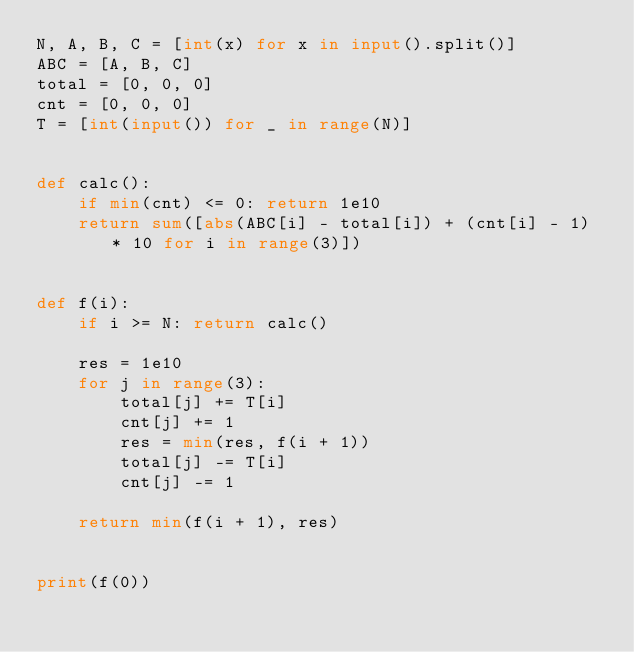<code> <loc_0><loc_0><loc_500><loc_500><_Python_>N, A, B, C = [int(x) for x in input().split()]
ABC = [A, B, C]
total = [0, 0, 0]
cnt = [0, 0, 0]
T = [int(input()) for _ in range(N)]


def calc():
    if min(cnt) <= 0: return 1e10
    return sum([abs(ABC[i] - total[i]) + (cnt[i] - 1) * 10 for i in range(3)])


def f(i):
    if i >= N: return calc()

    res = 1e10
    for j in range(3):
        total[j] += T[i]
        cnt[j] += 1
        res = min(res, f(i + 1))
        total[j] -= T[i]
        cnt[j] -= 1

    return min(f(i + 1), res)


print(f(0))
</code> 